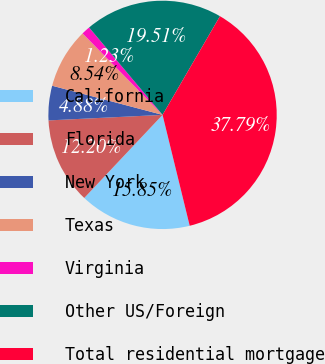Convert chart. <chart><loc_0><loc_0><loc_500><loc_500><pie_chart><fcel>California<fcel>Florida<fcel>New York<fcel>Texas<fcel>Virginia<fcel>Other US/Foreign<fcel>Total residential mortgage<nl><fcel>15.85%<fcel>12.2%<fcel>4.88%<fcel>8.54%<fcel>1.23%<fcel>19.51%<fcel>37.79%<nl></chart> 